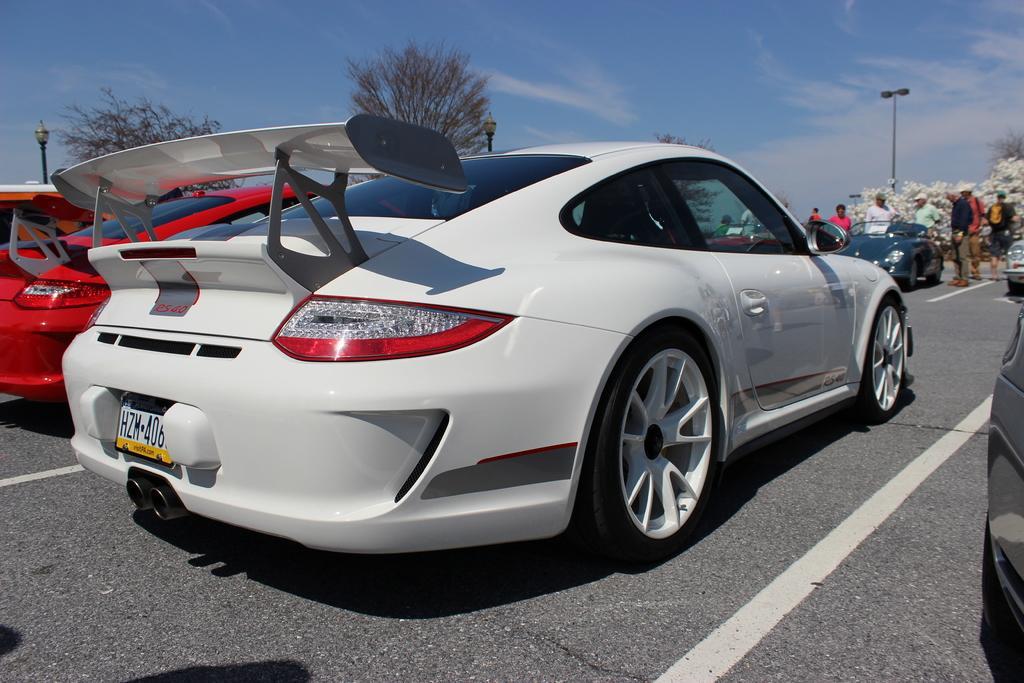Please provide a concise description of this image. In this picture I can see the vehicles on the road. I can see trees. I can see a few people near the car. I can see clouds in the sky. 